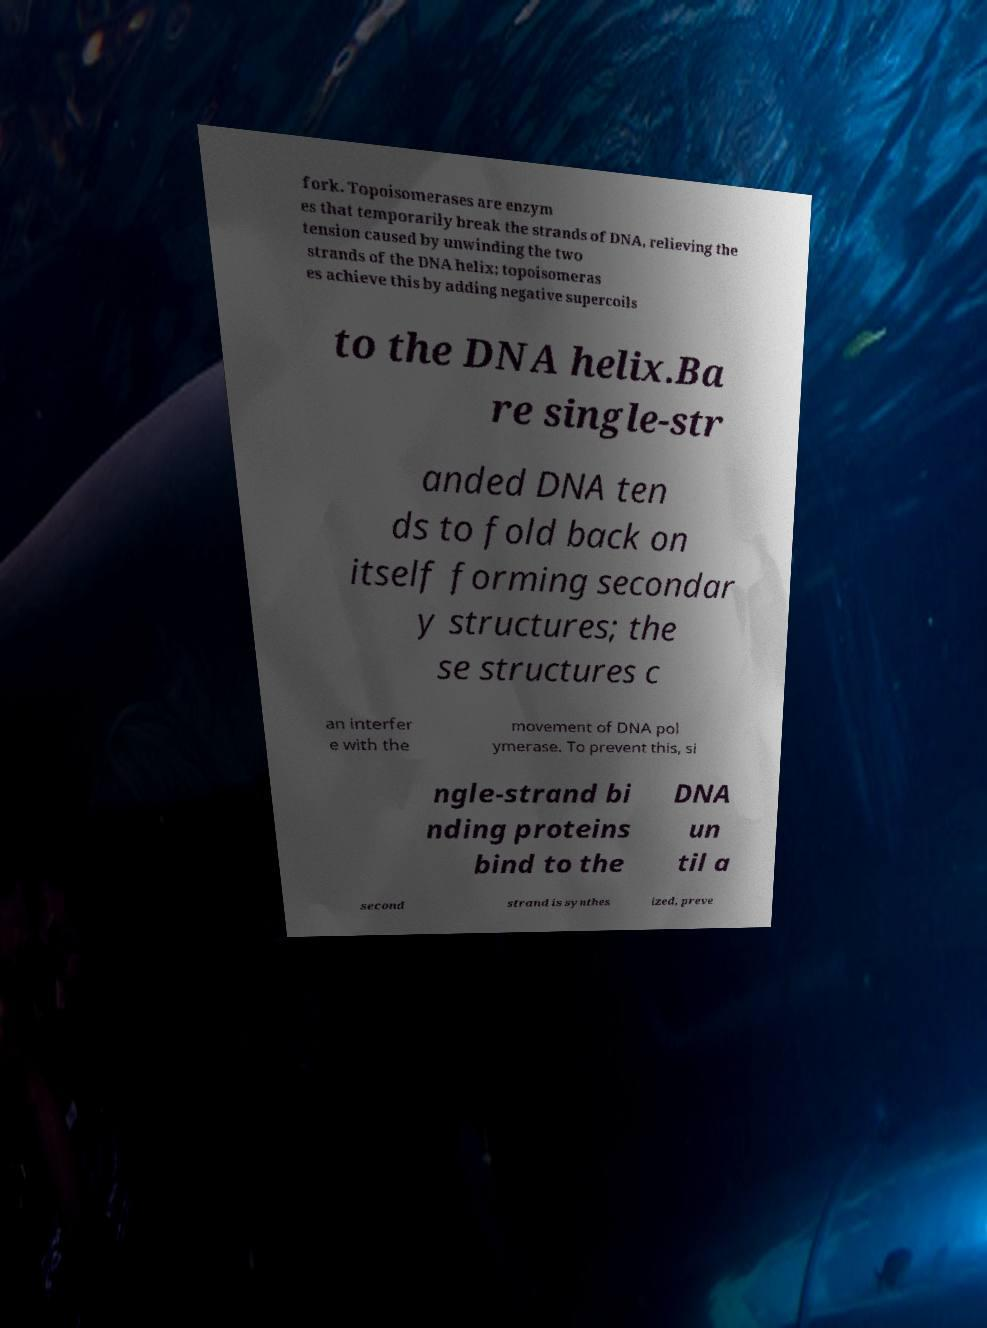There's text embedded in this image that I need extracted. Can you transcribe it verbatim? fork. Topoisomerases are enzym es that temporarily break the strands of DNA, relieving the tension caused by unwinding the two strands of the DNA helix; topoisomeras es achieve this by adding negative supercoils to the DNA helix.Ba re single-str anded DNA ten ds to fold back on itself forming secondar y structures; the se structures c an interfer e with the movement of DNA pol ymerase. To prevent this, si ngle-strand bi nding proteins bind to the DNA un til a second strand is synthes ized, preve 